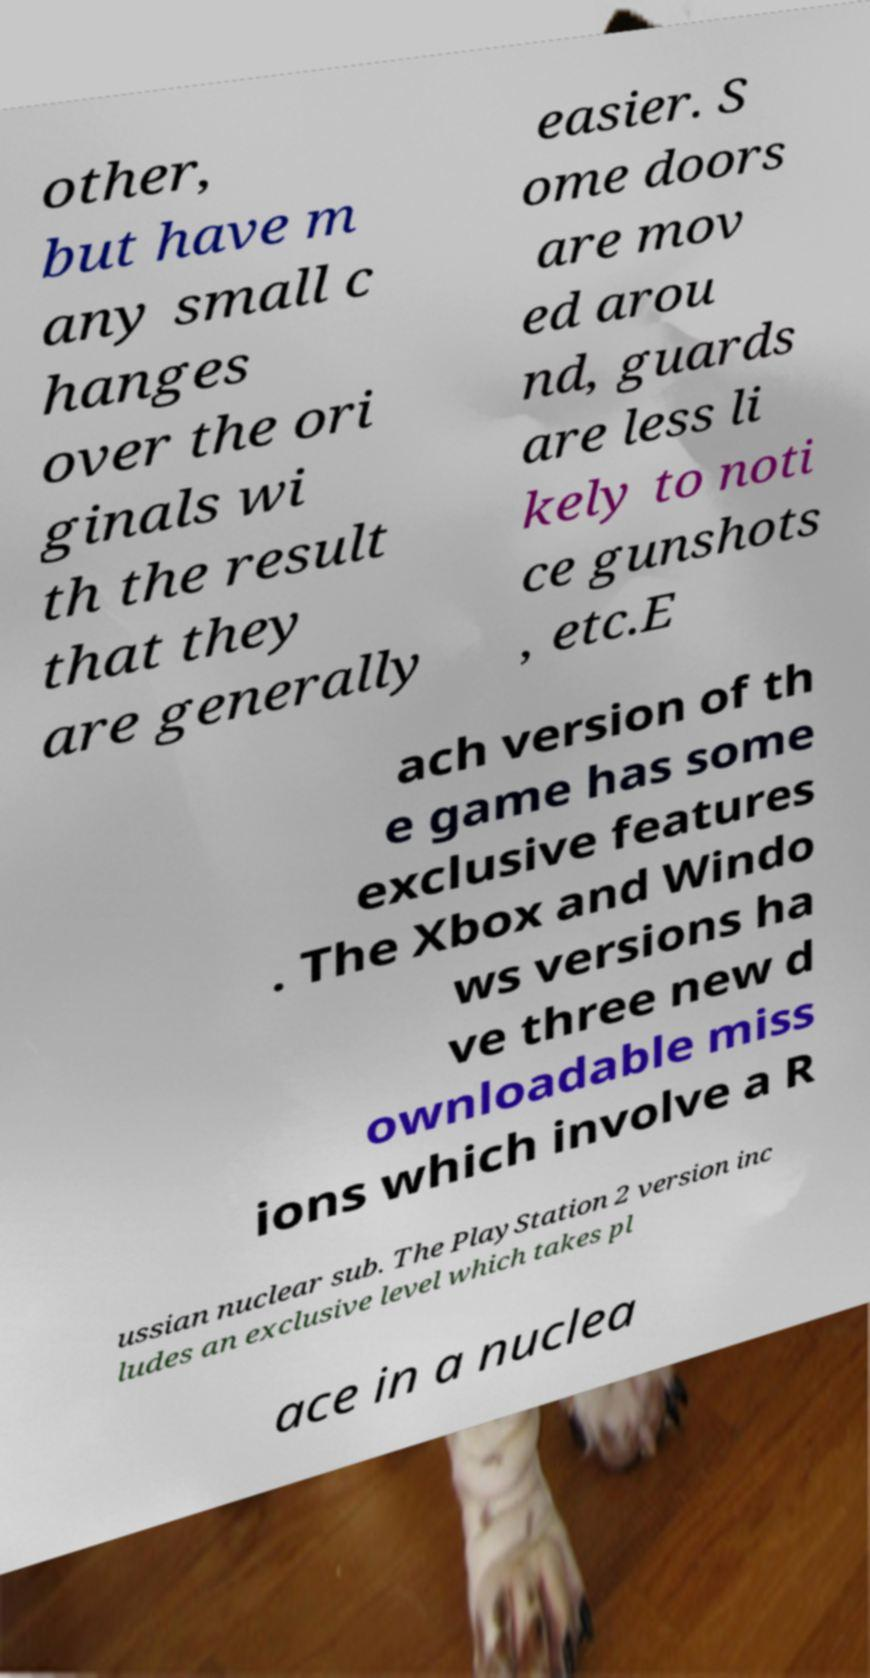What messages or text are displayed in this image? I need them in a readable, typed format. other, but have m any small c hanges over the ori ginals wi th the result that they are generally easier. S ome doors are mov ed arou nd, guards are less li kely to noti ce gunshots , etc.E ach version of th e game has some exclusive features . The Xbox and Windo ws versions ha ve three new d ownloadable miss ions which involve a R ussian nuclear sub. The PlayStation 2 version inc ludes an exclusive level which takes pl ace in a nuclea 